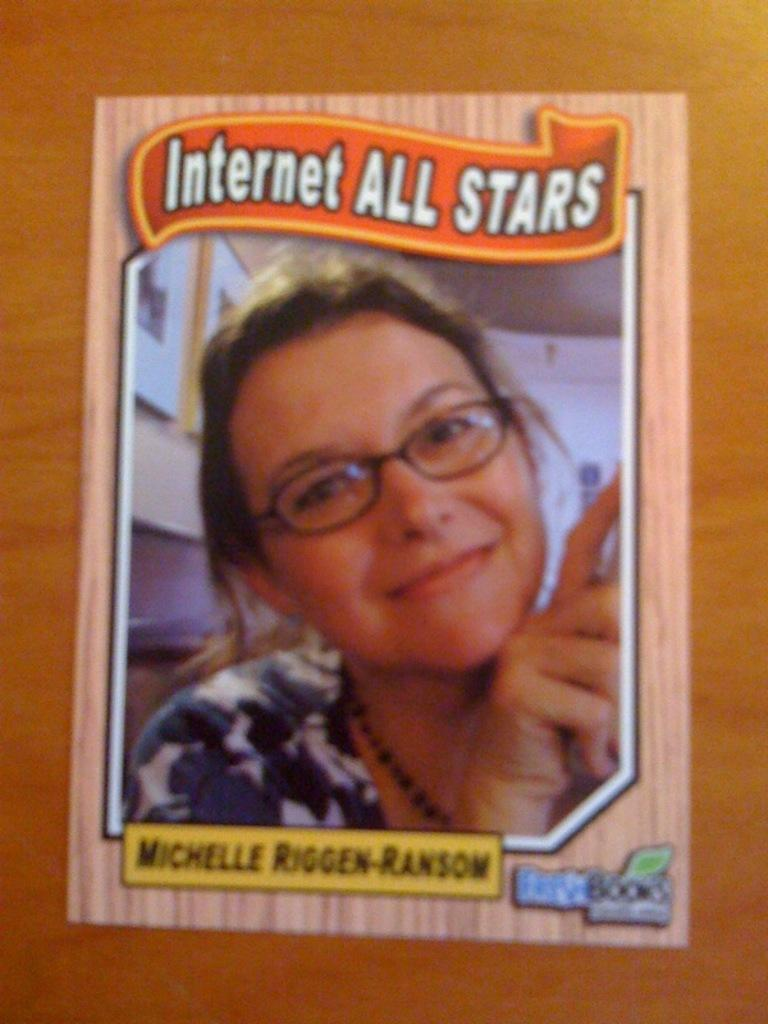What is the main object in the image? There is a book in the image. What is the book placed on? The book is on a wooden object. Is there any other visual element related to people in the image? Yes, there is a photo of a woman in the image. Can you describe the book's appearance? There is text on the book. What type of mint is growing near the book in the image? There is no mint present in the image; it only features a book, a wooden object, and a photo of a woman. 